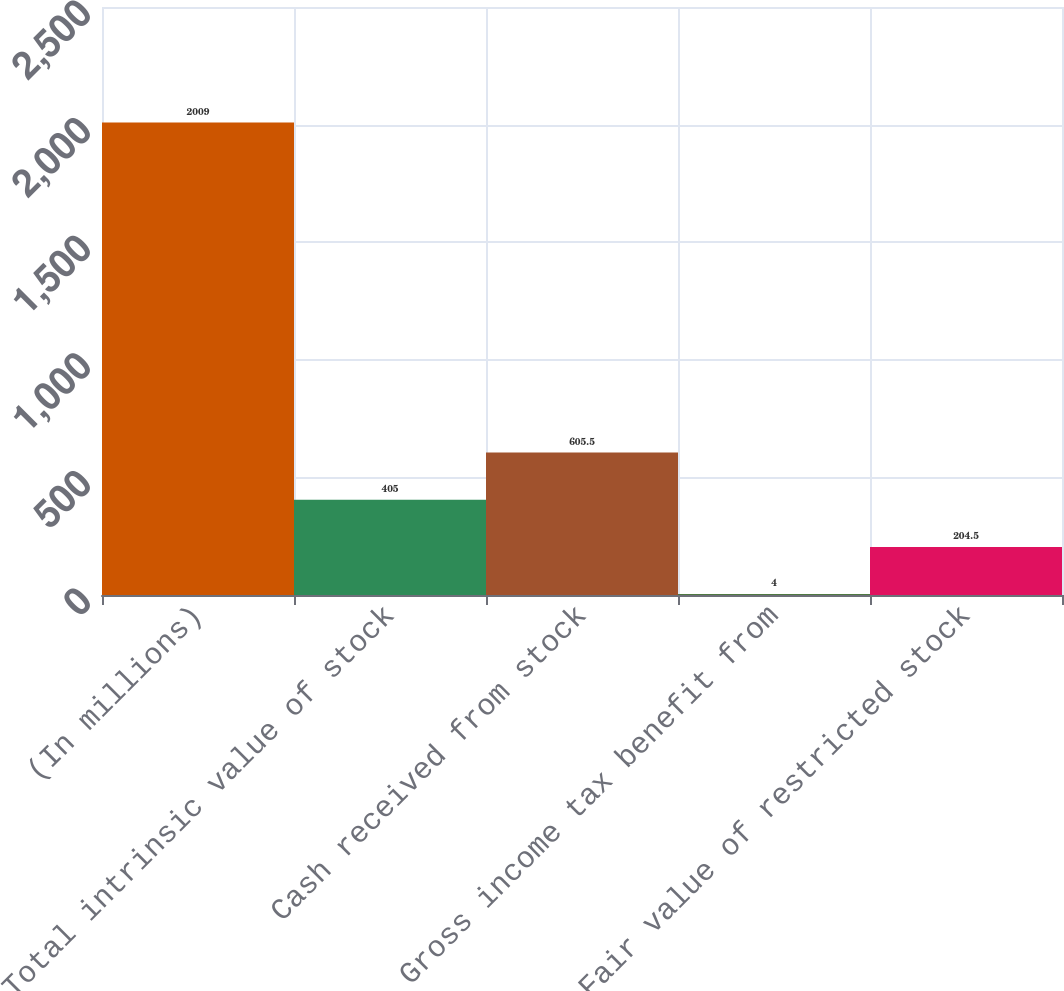Convert chart. <chart><loc_0><loc_0><loc_500><loc_500><bar_chart><fcel>(In millions)<fcel>Total intrinsic value of stock<fcel>Cash received from stock<fcel>Gross income tax benefit from<fcel>Fair value of restricted stock<nl><fcel>2009<fcel>405<fcel>605.5<fcel>4<fcel>204.5<nl></chart> 